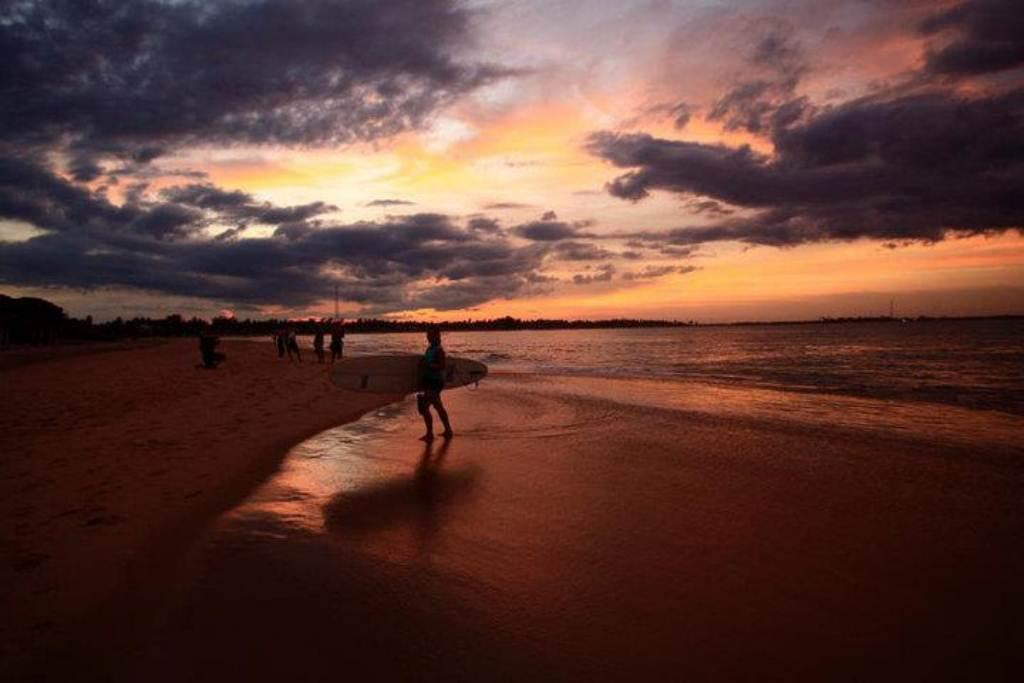What is the person in the image holding? The person in the image is holding a surfboard. What type of surface are the people standing on? The people are standing on sand in the image. What can be seen in the background of the image? The sky with clouds is visible in the background of the image. What is the natural environment present in the image? Water and trees are visible in the image. What type of record is being played in the image? There is no record present in the image; it features a person holding a surfboard and people standing on sand near water and trees. 